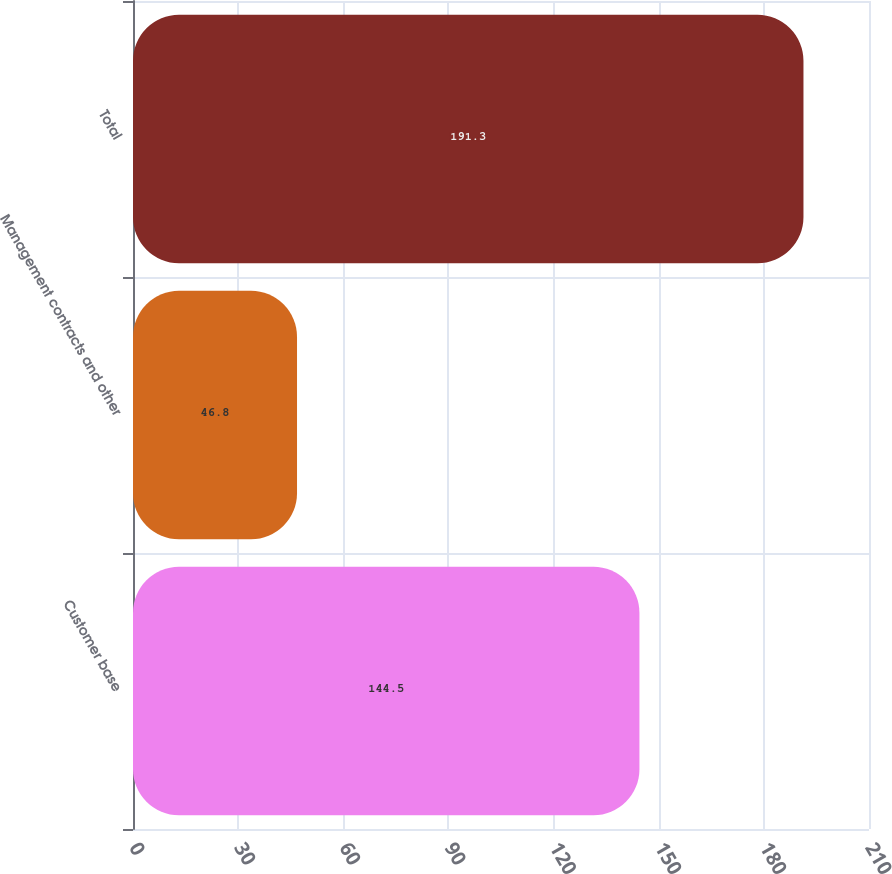Convert chart. <chart><loc_0><loc_0><loc_500><loc_500><bar_chart><fcel>Customer base<fcel>Management contracts and other<fcel>Total<nl><fcel>144.5<fcel>46.8<fcel>191.3<nl></chart> 